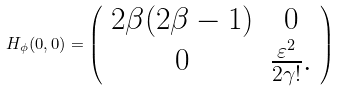<formula> <loc_0><loc_0><loc_500><loc_500>H _ { \phi } ( 0 , 0 ) = \left ( \begin{array} { c c } 2 \beta ( 2 \beta - 1 ) & 0 \\ 0 & \frac { \varepsilon ^ { 2 } } { 2 \gamma ! } . \end{array} \right )</formula> 